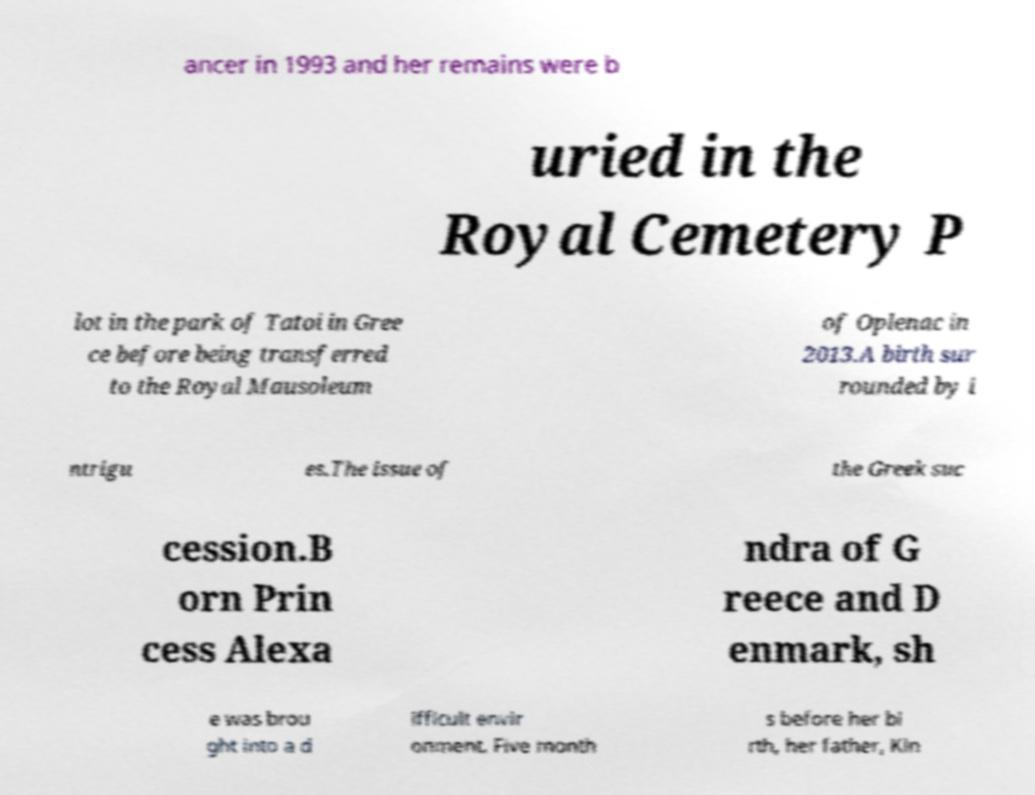Could you extract and type out the text from this image? ancer in 1993 and her remains were b uried in the Royal Cemetery P lot in the park of Tatoi in Gree ce before being transferred to the Royal Mausoleum of Oplenac in 2013.A birth sur rounded by i ntrigu es.The issue of the Greek suc cession.B orn Prin cess Alexa ndra of G reece and D enmark, sh e was brou ght into a d ifficult envir onment. Five month s before her bi rth, her father, Kin 